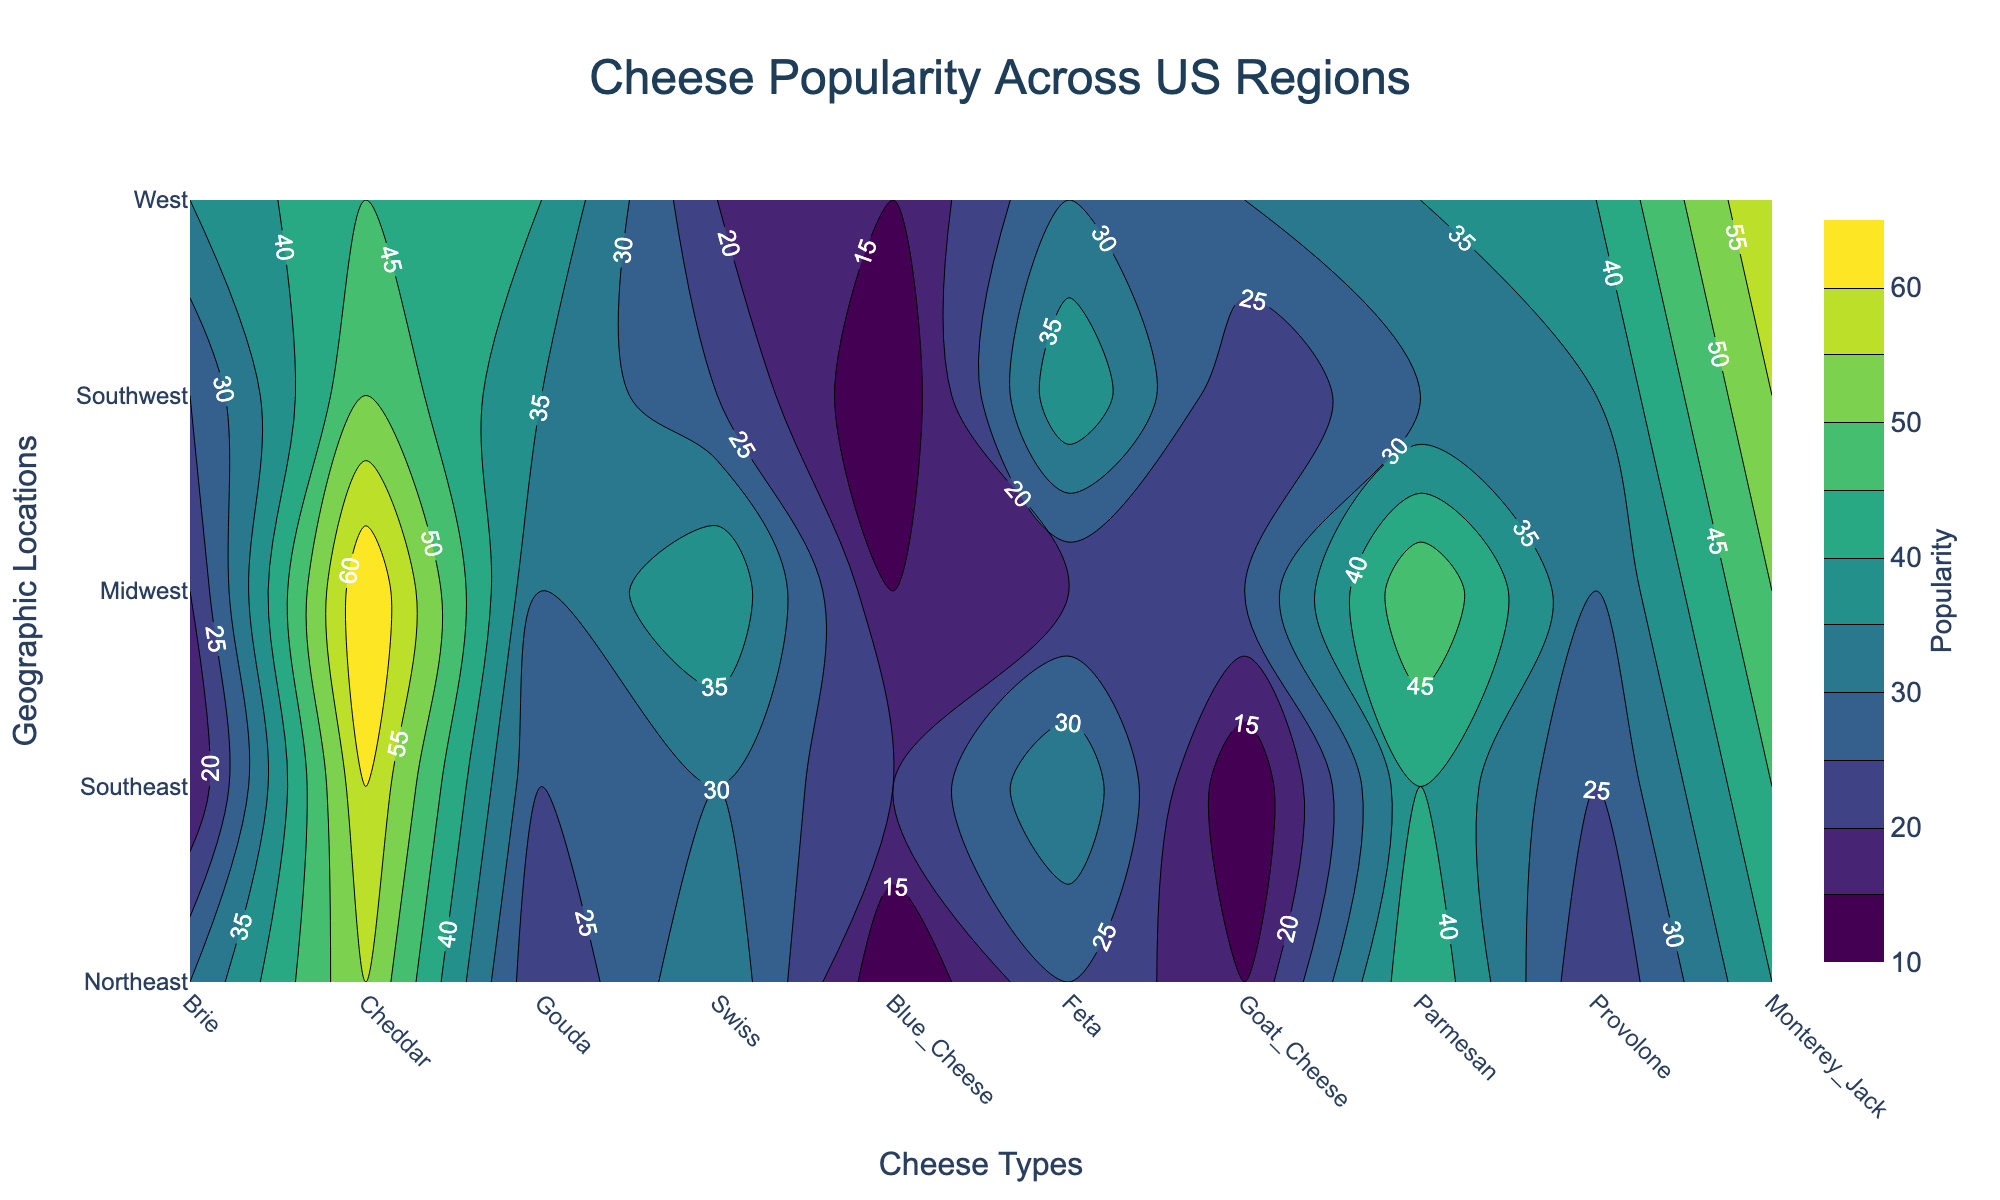What is the title of the contour plot? The title of the contour plot is typically displayed prominently at the top of the figure, usually in larger font size.
Answer: Cheese Popularity Across US Regions Which region has the highest popularity for Gouda cheese? To find the region with the highest popularity for Gouda, look for the highest contour labels or the darkest regions corresponding to Gouda's x-axis location.
Answer: West In which region is Cheddar cheese the most popular? Locate the Cheddar cheese axis and find the region with the highest contour label or the darkest color.
Answer: Midwest What is the overall popularity trend for Blue Cheese across regions? Look at the contour levels for the Blue Cheese axis. Notice if the contours are lower (lighter) or higher (darker) and observe how they change from region to region.
Answer: Generally low Which cheese type is equally popular in the Midwest and Southeast regions? Compare the contour levels for each cheese type along the Midwest and Southeast rows. Look for similar contour labels or color intensity.
Answer: Provolone What is the average popularity of Parmesan cheese across all regions? Summing the popularity values for Parmesan across all regions and then dividing by the number of regions will provide the average. (45 + 40 + 50 + 30 + 35)/5 = 200/5
Answer: 40 Which region shows the lowest popularity for Swiss cheese? Find the Swiss cheese axis and identify the region with the lowest contour label or the lightest color.
Answer: West Between Brie and Feta, which cheese is more popular in the Northeast? Compare the contour labels or color intensity for Brie and Feta in the Northeast row.
Answer: Brie How does the popularity of Monterey Jack cheese change from the Northeast to the West? Track the contour labels or color intensity for Monterey Jack across these two regions to note any increases or decreases.
Answer: Increases Which cheese is the most consistently popular across all regions? Identify the cheese type with the least color variation and contour level changes across all regions.
Answer: Cheddar 